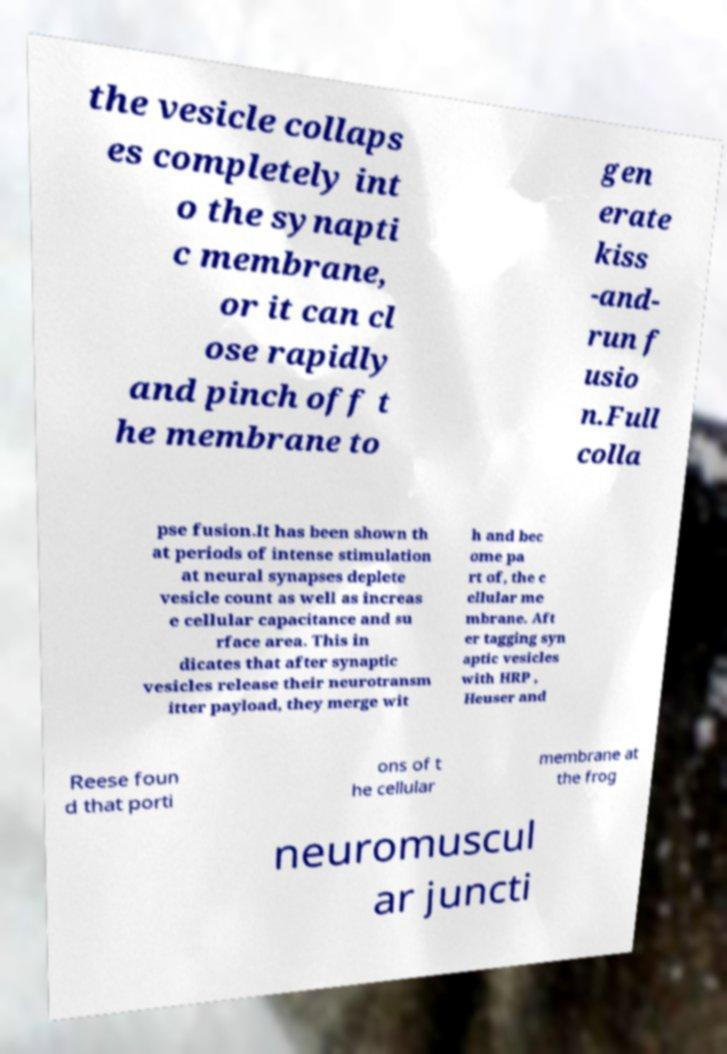For documentation purposes, I need the text within this image transcribed. Could you provide that? the vesicle collaps es completely int o the synapti c membrane, or it can cl ose rapidly and pinch off t he membrane to gen erate kiss -and- run f usio n.Full colla pse fusion.It has been shown th at periods of intense stimulation at neural synapses deplete vesicle count as well as increas e cellular capacitance and su rface area. This in dicates that after synaptic vesicles release their neurotransm itter payload, they merge wit h and bec ome pa rt of, the c ellular me mbrane. Aft er tagging syn aptic vesicles with HRP , Heuser and Reese foun d that porti ons of t he cellular membrane at the frog neuromuscul ar juncti 